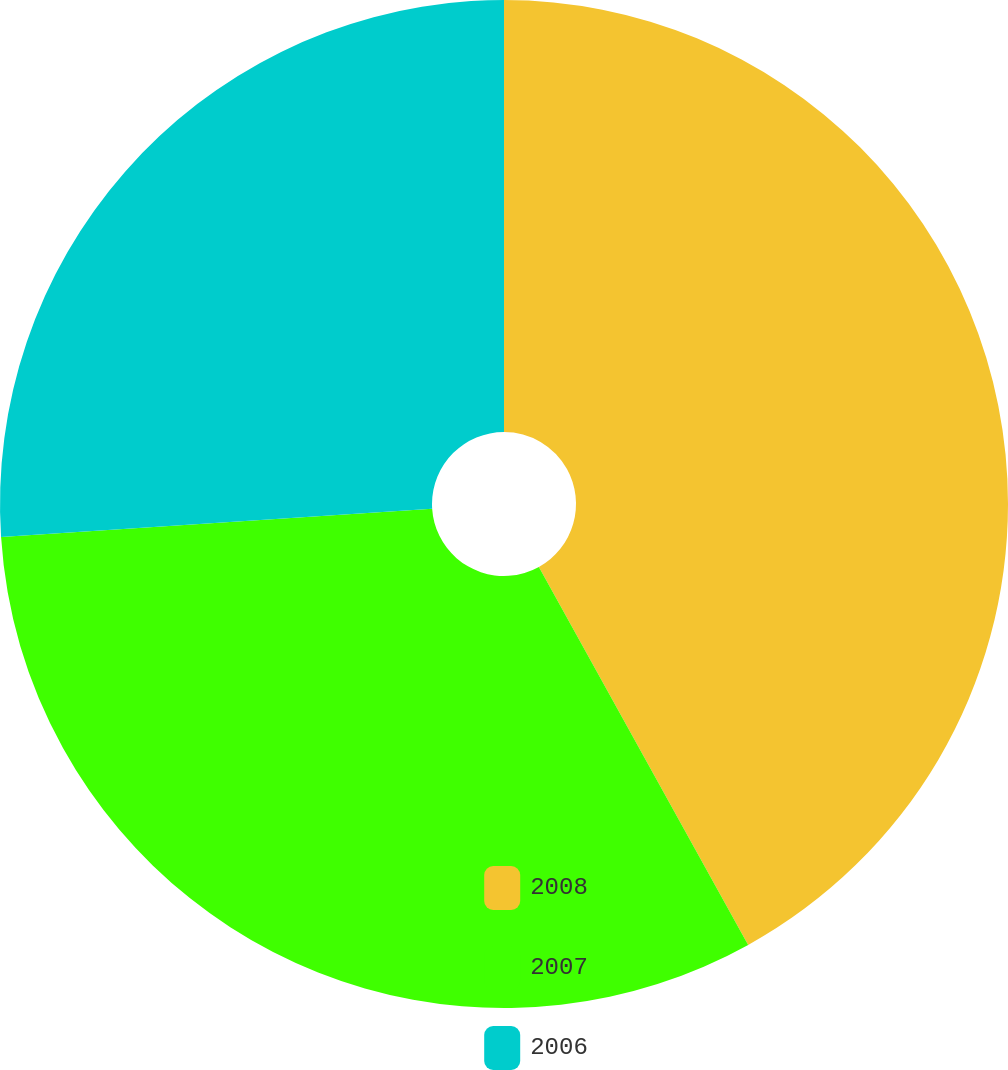Convert chart. <chart><loc_0><loc_0><loc_500><loc_500><pie_chart><fcel>2008<fcel>2007<fcel>2006<nl><fcel>41.95%<fcel>32.01%<fcel>26.04%<nl></chart> 